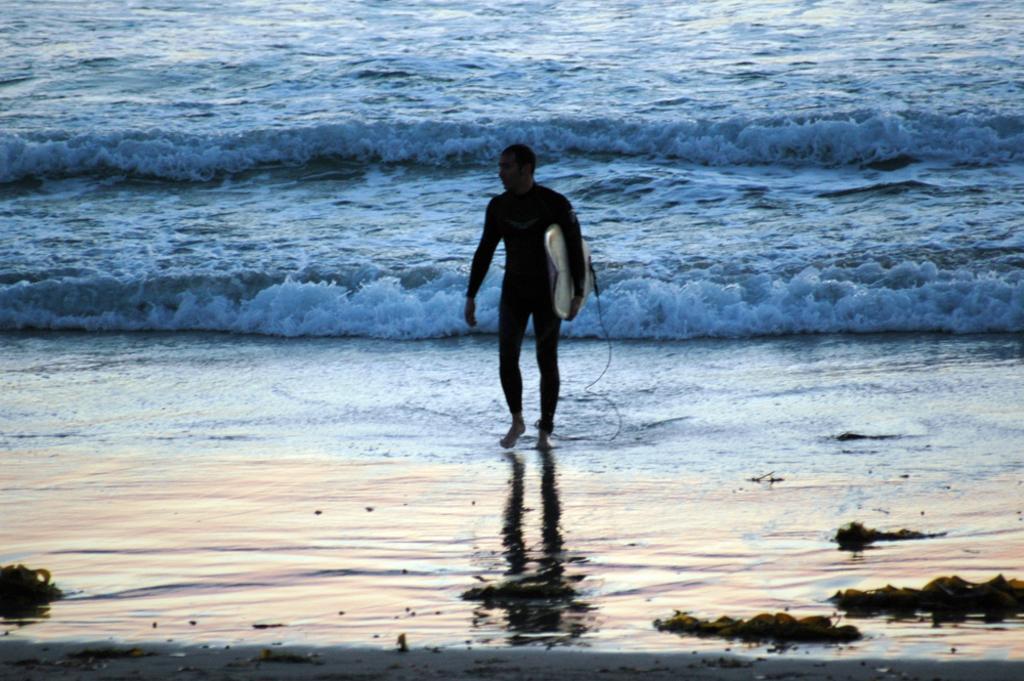Please provide a concise description of this image. In this picture we can see man walking and holding surfboard with his hand and in background we can see water waves. 